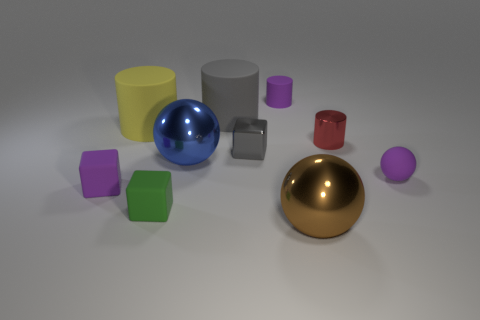Subtract 1 blocks. How many blocks are left? 2 Subtract all rubber blocks. How many blocks are left? 1 Add 4 small red matte spheres. How many small red matte spheres exist? 4 Subtract all yellow cylinders. How many cylinders are left? 3 Subtract 0 gray spheres. How many objects are left? 10 Subtract all cylinders. How many objects are left? 6 Subtract all gray cylinders. Subtract all gray spheres. How many cylinders are left? 3 Subtract all cyan blocks. How many brown cylinders are left? 0 Subtract all small shiny things. Subtract all tiny metallic blocks. How many objects are left? 7 Add 4 small cubes. How many small cubes are left? 7 